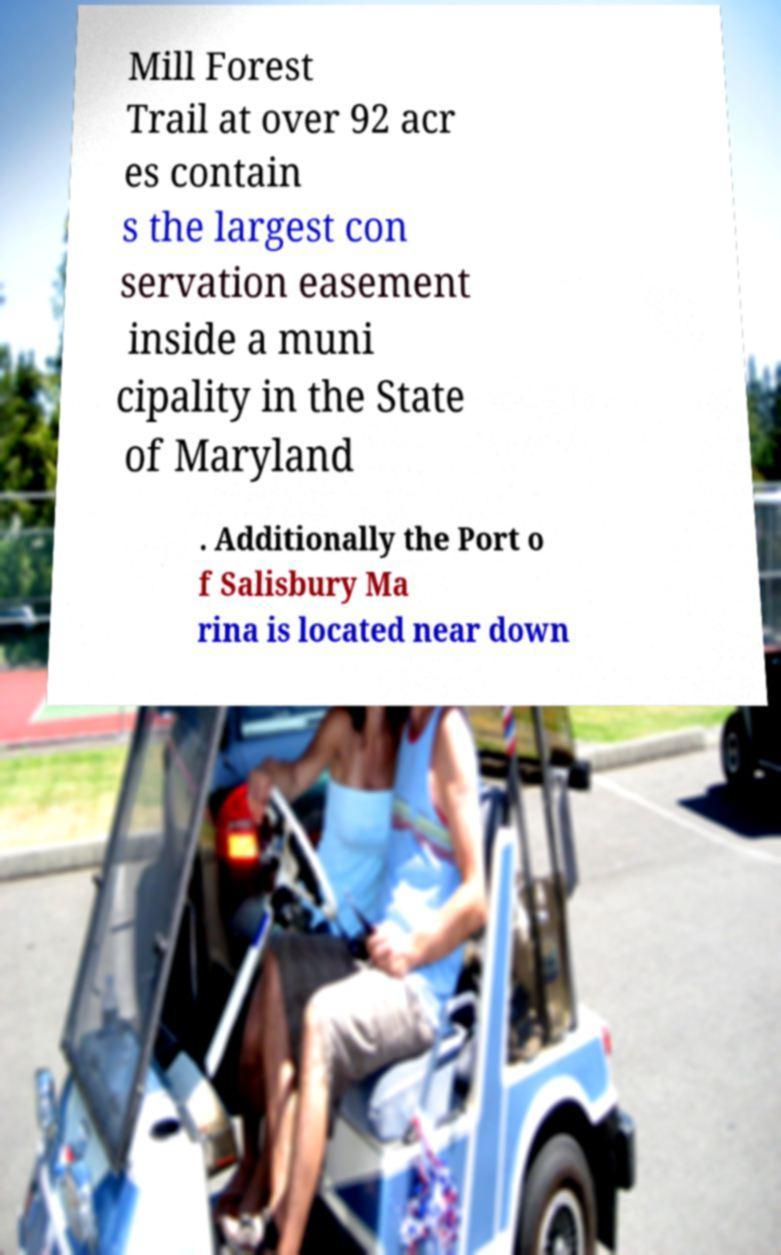Can you read and provide the text displayed in the image?This photo seems to have some interesting text. Can you extract and type it out for me? Mill Forest Trail at over 92 acr es contain s the largest con servation easement inside a muni cipality in the State of Maryland . Additionally the Port o f Salisbury Ma rina is located near down 